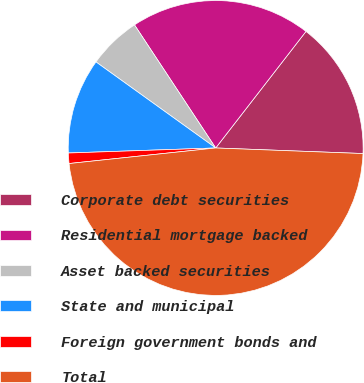<chart> <loc_0><loc_0><loc_500><loc_500><pie_chart><fcel>Corporate debt securities<fcel>Residential mortgage backed<fcel>Asset backed securities<fcel>State and municipal<fcel>Foreign government bonds and<fcel>Total<nl><fcel>15.11%<fcel>19.77%<fcel>5.8%<fcel>10.46%<fcel>1.14%<fcel>47.71%<nl></chart> 